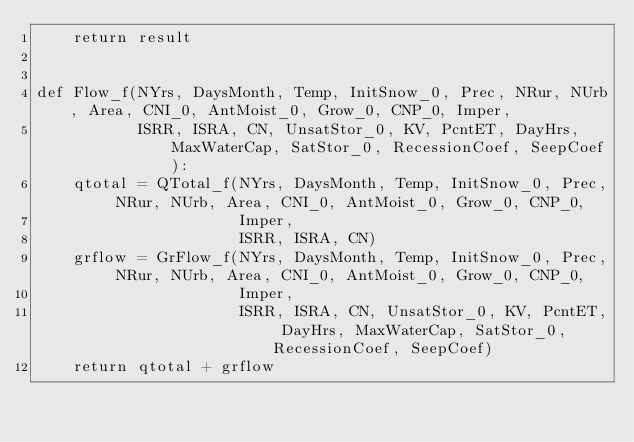<code> <loc_0><loc_0><loc_500><loc_500><_Python_>    return result


def Flow_f(NYrs, DaysMonth, Temp, InitSnow_0, Prec, NRur, NUrb, Area, CNI_0, AntMoist_0, Grow_0, CNP_0, Imper,
           ISRR, ISRA, CN, UnsatStor_0, KV, PcntET, DayHrs, MaxWaterCap, SatStor_0, RecessionCoef, SeepCoef):
    qtotal = QTotal_f(NYrs, DaysMonth, Temp, InitSnow_0, Prec, NRur, NUrb, Area, CNI_0, AntMoist_0, Grow_0, CNP_0,
                      Imper,
                      ISRR, ISRA, CN)
    grflow = GrFlow_f(NYrs, DaysMonth, Temp, InitSnow_0, Prec, NRur, NUrb, Area, CNI_0, AntMoist_0, Grow_0, CNP_0,
                      Imper,
                      ISRR, ISRA, CN, UnsatStor_0, KV, PcntET, DayHrs, MaxWaterCap, SatStor_0, RecessionCoef, SeepCoef)
    return qtotal + grflow
</code> 